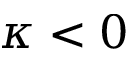<formula> <loc_0><loc_0><loc_500><loc_500>\kappa < 0</formula> 